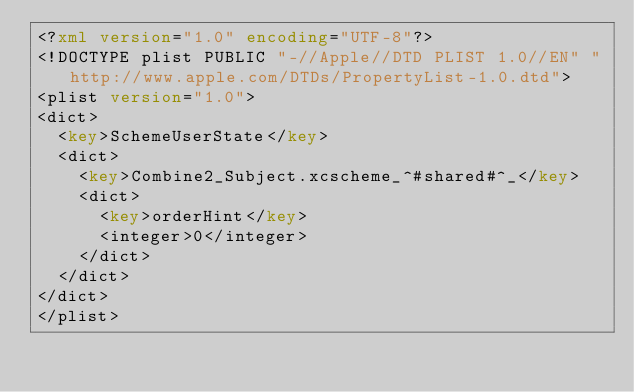Convert code to text. <code><loc_0><loc_0><loc_500><loc_500><_XML_><?xml version="1.0" encoding="UTF-8"?>
<!DOCTYPE plist PUBLIC "-//Apple//DTD PLIST 1.0//EN" "http://www.apple.com/DTDs/PropertyList-1.0.dtd">
<plist version="1.0">
<dict>
	<key>SchemeUserState</key>
	<dict>
		<key>Combine2_Subject.xcscheme_^#shared#^_</key>
		<dict>
			<key>orderHint</key>
			<integer>0</integer>
		</dict>
	</dict>
</dict>
</plist>
</code> 